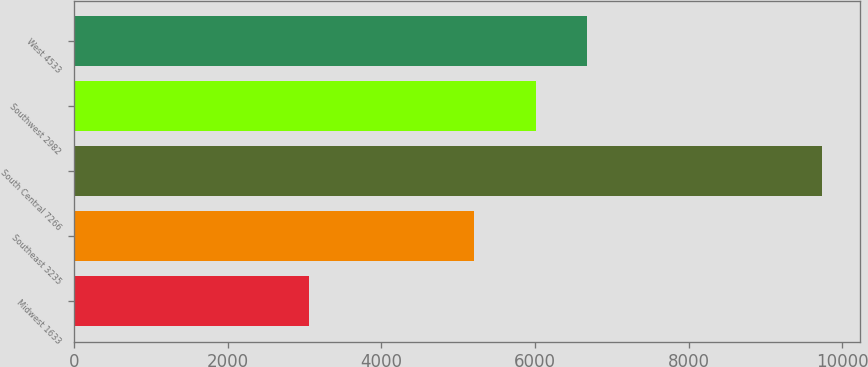<chart> <loc_0><loc_0><loc_500><loc_500><bar_chart><fcel>Midwest 1633<fcel>Southeast 3235<fcel>South Central 7266<fcel>Southwest 2982<fcel>West 4533<nl><fcel>3065<fcel>5206<fcel>9740<fcel>6017<fcel>6684.5<nl></chart> 